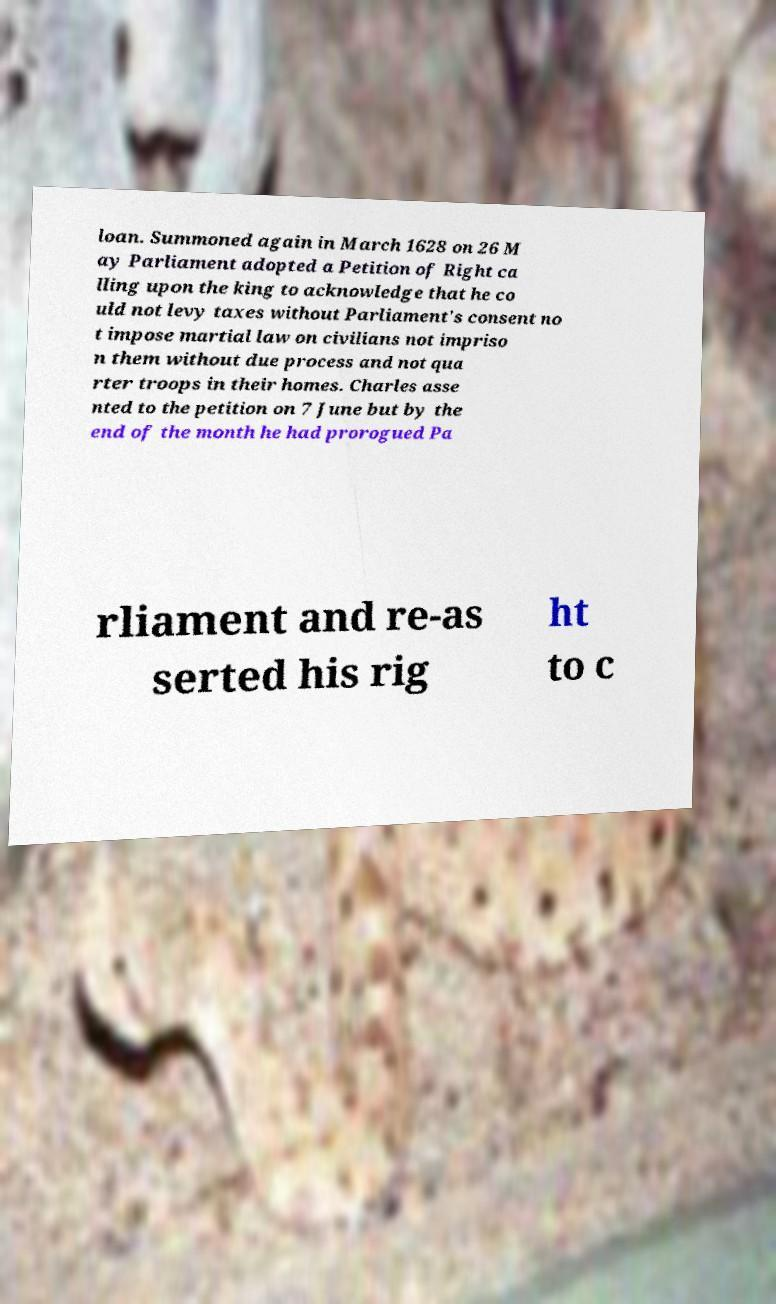There's text embedded in this image that I need extracted. Can you transcribe it verbatim? loan. Summoned again in March 1628 on 26 M ay Parliament adopted a Petition of Right ca lling upon the king to acknowledge that he co uld not levy taxes without Parliament's consent no t impose martial law on civilians not impriso n them without due process and not qua rter troops in their homes. Charles asse nted to the petition on 7 June but by the end of the month he had prorogued Pa rliament and re-as serted his rig ht to c 